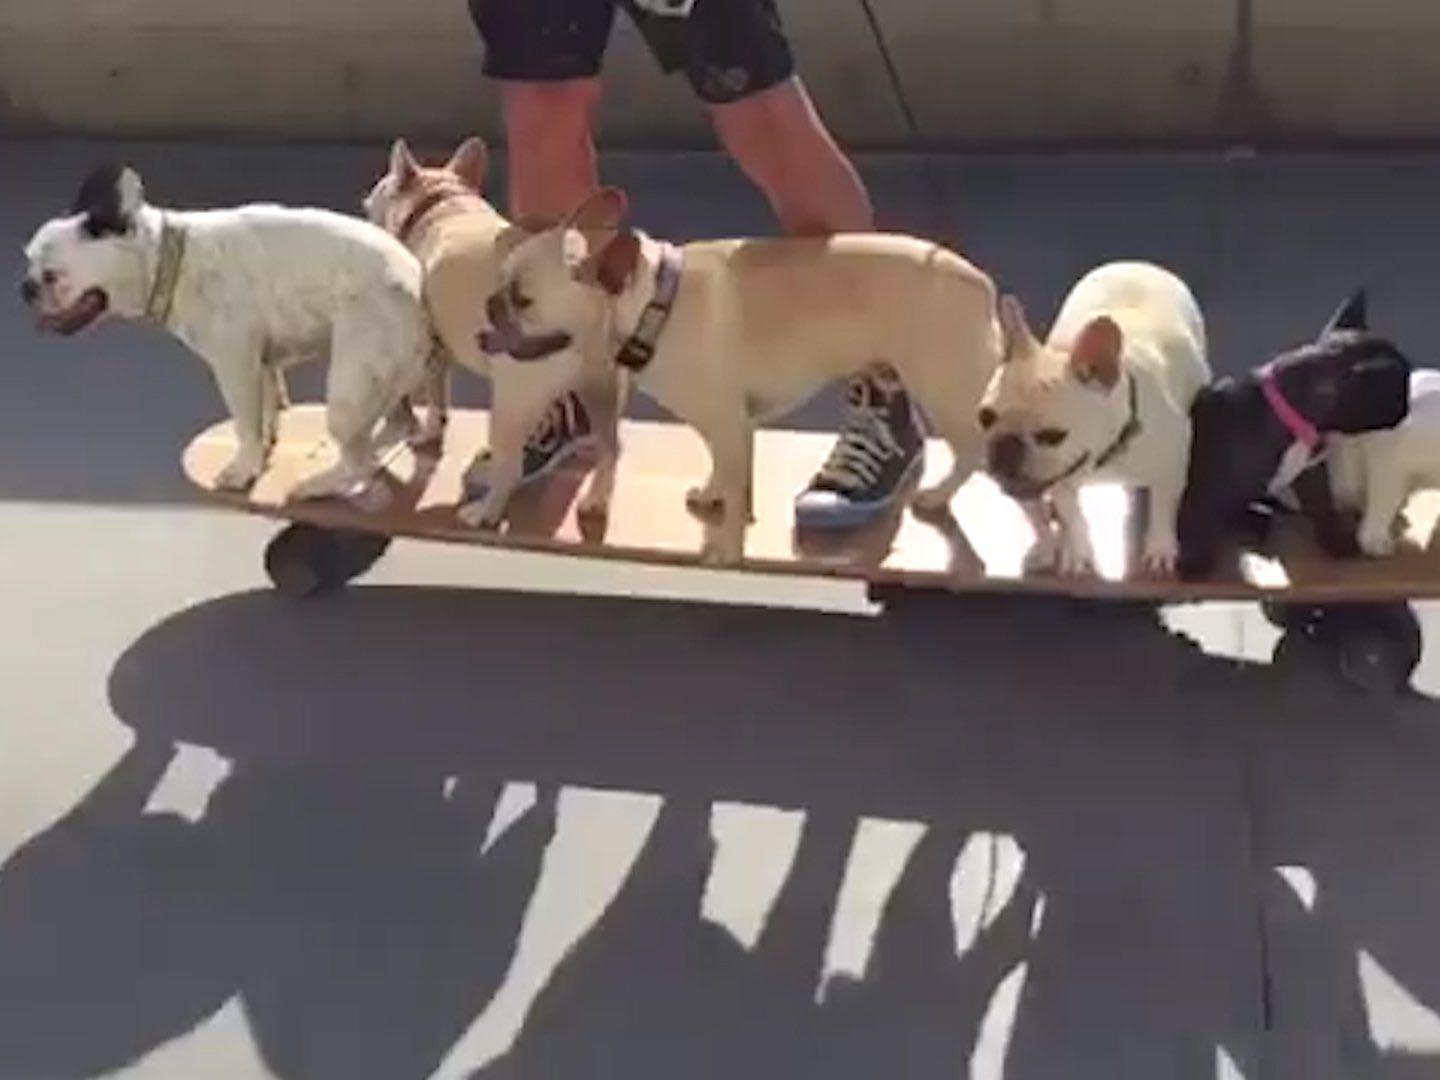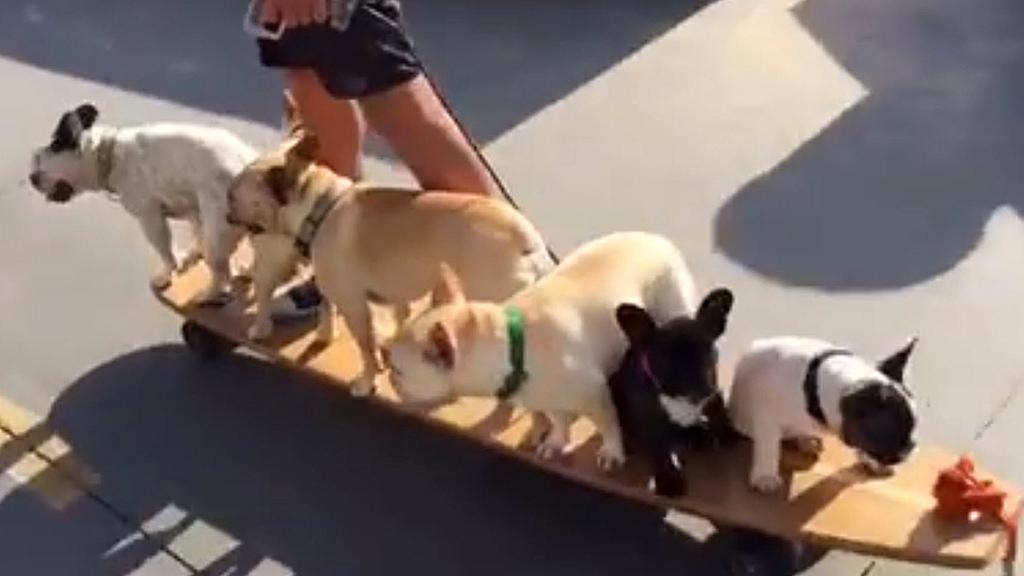The first image is the image on the left, the second image is the image on the right. Evaluate the accuracy of this statement regarding the images: "At least one image features more than one dog on a skateboard.". Is it true? Answer yes or no. Yes. 